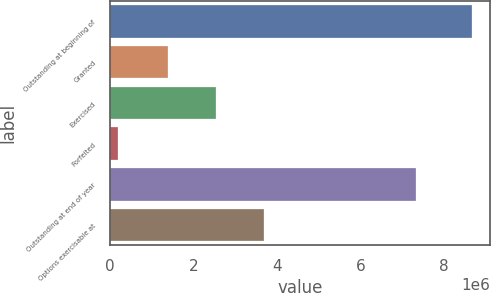Convert chart to OTSL. <chart><loc_0><loc_0><loc_500><loc_500><bar_chart><fcel>Outstanding at beginning of<fcel>Granted<fcel>Exercised<fcel>Forfeited<fcel>Outstanding at end of year<fcel>Options exercisable at<nl><fcel>8.66034e+06<fcel>1.38758e+06<fcel>2.53758e+06<fcel>190958<fcel>7.31938e+06<fcel>3.67373e+06<nl></chart> 